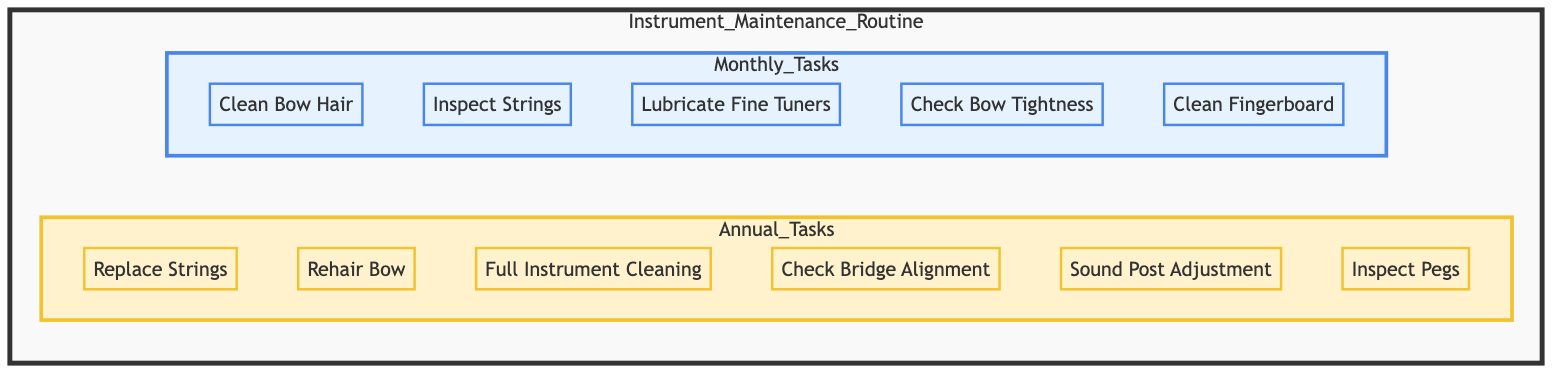What are the monthly tasks listed in the diagram? The diagram provides a list of tasks under the "Monthly Tasks" section. These tasks include: Clean Bow Hair, Inspect Strings, Lubricate Fine Tuners, Check Bow Tightness, and Clean Fingerboard.
Answer: Clean Bow Hair, Inspect Strings, Lubricate Fine Tuners, Check Bow Tightness, Clean Fingerboard How many tasks are outlined in the Annual Tasks section? The diagram shows a dedicated section for "Annual Tasks," which contains six tasks: Replace Strings, Rehair Bow, Full Instrument Cleaning, Check Bridge Alignment, Sound Post Adjustment, and Inspect Pegs.
Answer: 6 What is the first task listed under Monthly Tasks? Looking at the monthly tasks section within the flowchart, the very first task listed is "Clean Bow Hair."
Answer: Clean Bow Hair Which task requires a professional luthier's assistance? The diagram indicates that two specific tasks, "Rehair Bow" and "Sound Post Adjustment," require a professional luthier's help. However, only one directly mentions taking the bow to a luthier, which is "Rehair Bow."
Answer: Rehair Bow What relationship exists between Instrument Maintenance Routine and Monthly Tasks? The flowchart indicates a direct flow from "Instrument Maintenance Routine" to "Monthly Tasks," suggesting that the maintenance routine includes the monthly tasks as part of its overall structure. This hierarchical relationship shows that monthly tasks are components of the broader maintenance routine.
Answer: Direct flow relationship How many total tasks are there in the Instrument Maintenance Routine? To find the total tasks, one must add the number of monthly tasks (5) and the number of annual tasks (6). Therefore, the total number of tasks in the routine is 5 + 6, which equals 11.
Answer: 11 